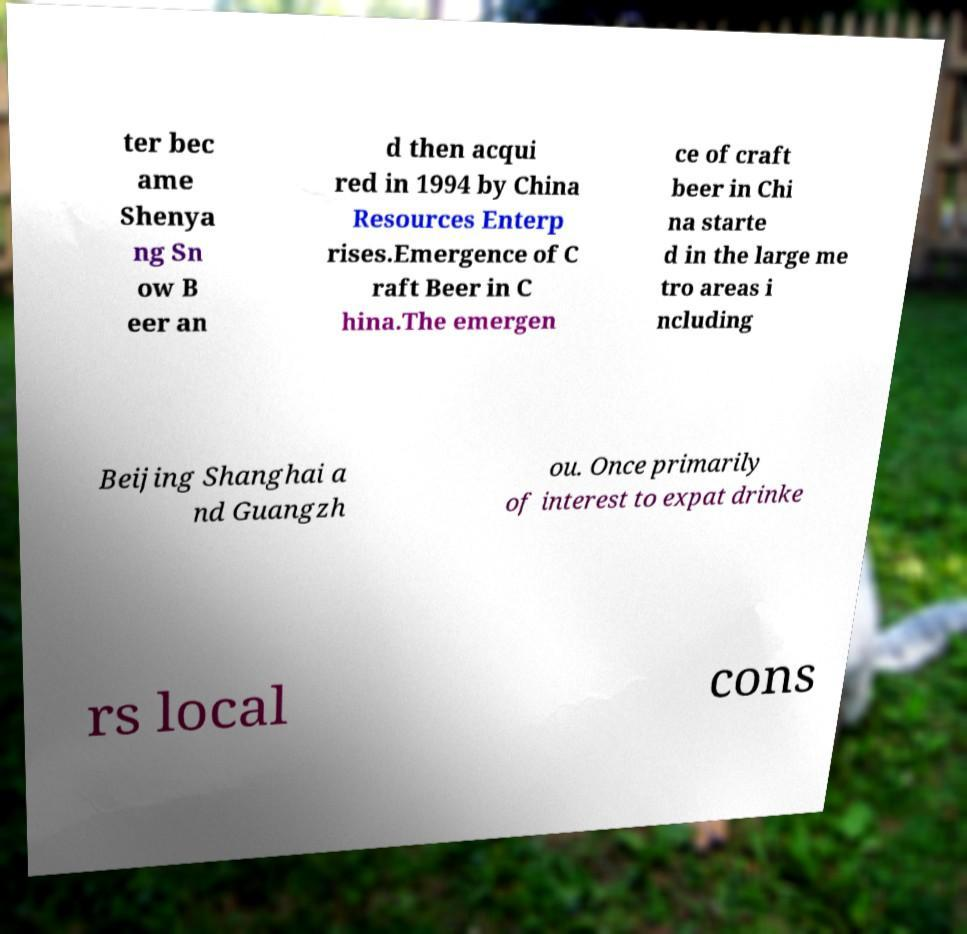Could you assist in decoding the text presented in this image and type it out clearly? ter bec ame Shenya ng Sn ow B eer an d then acqui red in 1994 by China Resources Enterp rises.Emergence of C raft Beer in C hina.The emergen ce of craft beer in Chi na starte d in the large me tro areas i ncluding Beijing Shanghai a nd Guangzh ou. Once primarily of interest to expat drinke rs local cons 